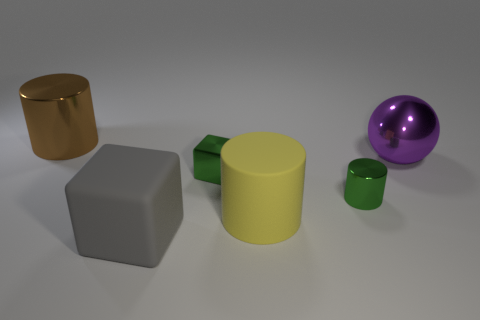Subtract all big cylinders. How many cylinders are left? 1 Add 2 large green metal cylinders. How many objects exist? 8 Subtract all cyan cylinders. Subtract all purple blocks. How many cylinders are left? 3 Subtract all spheres. How many objects are left? 5 Subtract all big purple metallic balls. Subtract all purple metallic objects. How many objects are left? 4 Add 3 large purple metallic things. How many large purple metallic things are left? 4 Add 3 large purple metal balls. How many large purple metal balls exist? 4 Subtract 0 yellow blocks. How many objects are left? 6 